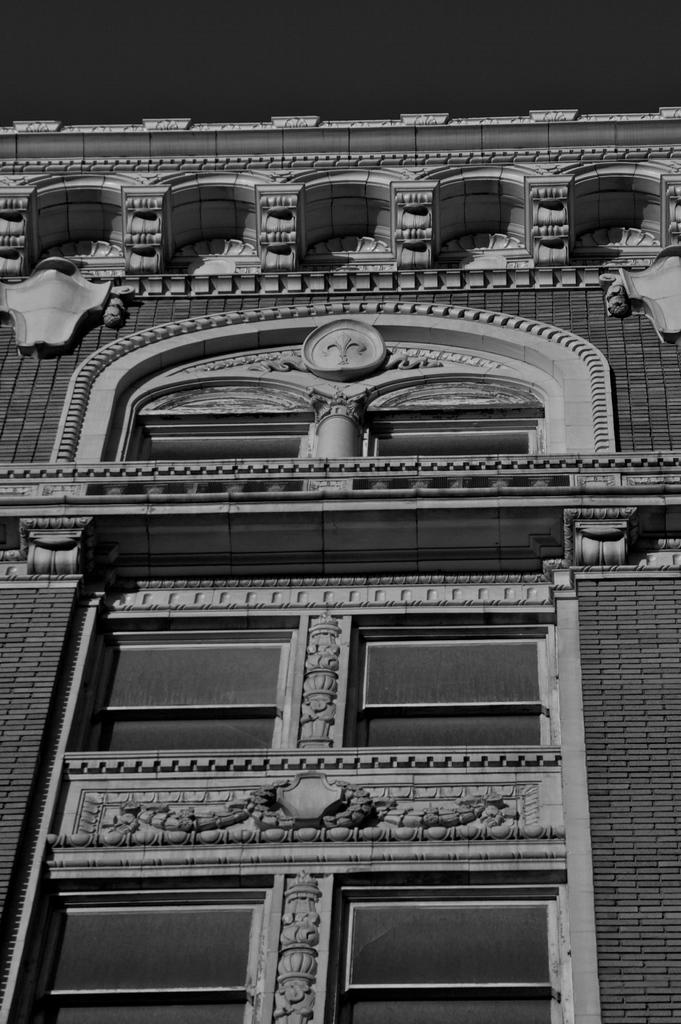What type of structure is visible in the image? There is a building in the image. What architectural feature can be seen on the building? The building has an arch. Are there any decorative elements on the building? Yes, the building has sculptures. What allows natural light to enter the building? The building has windows. What type of humor is being used in the building's operation? There is no humor or operation present in the image; it only shows a building with an arch, sculptures, and windows. 